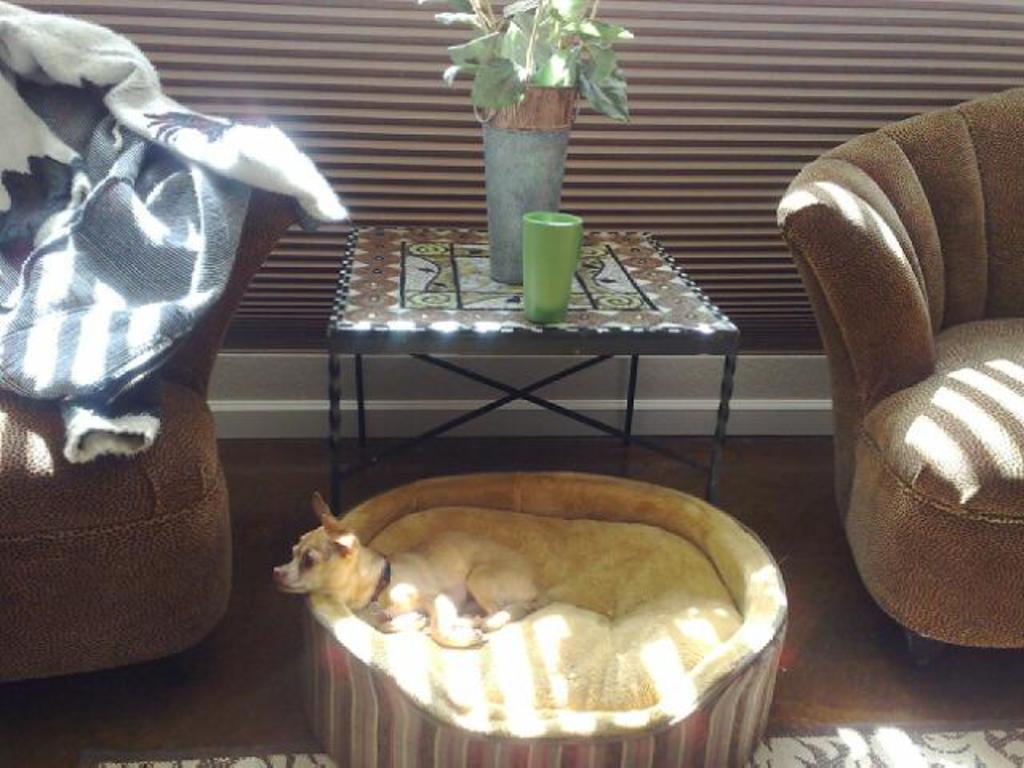Describe this image in one or two sentences. There are two sofas in the room. There is a dog which is sleeping on its bed. There is a table on which a flower pot and a glass was placed. In the background there is a wall. 